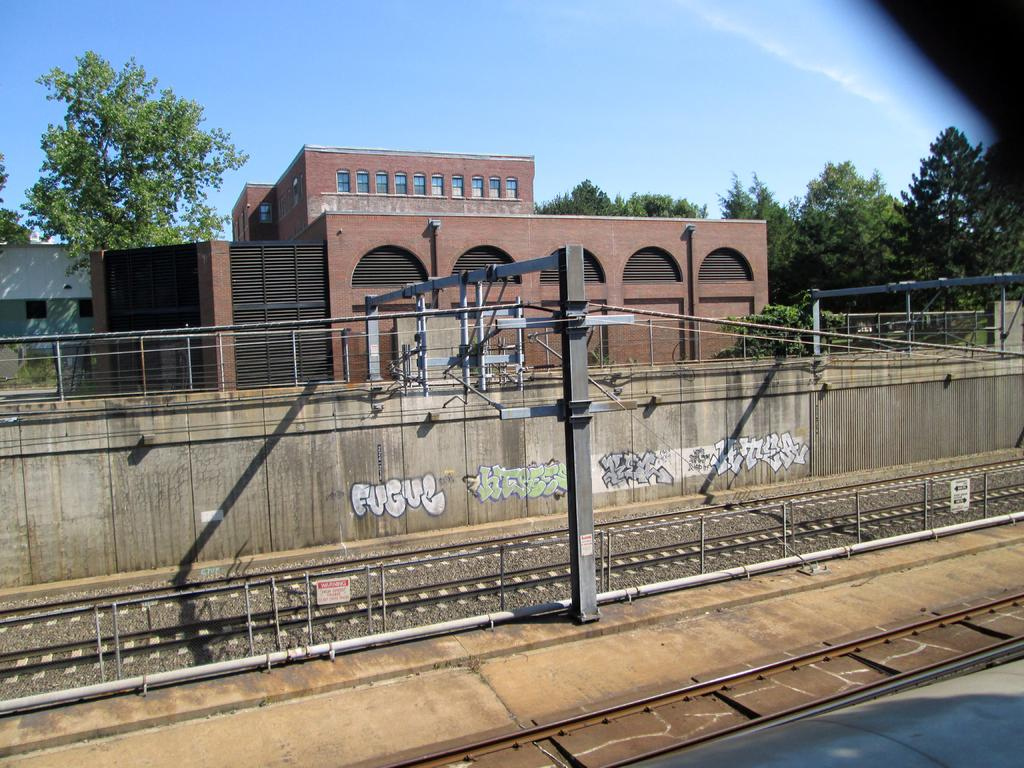What type of structures can be seen in the image? There are buildings in the image. What natural elements are present in the image? There are trees in the image. What man-made objects can be seen in the image? There are poles and wires in the image. What transportation-related feature is visible in the image? There are railway tracks in the image. What can be seen in the background of the image? The sky is visible in the background of the image. What advice is being given by the blade in the image? There is no blade present in the image, and therefore no advice can be given. Can you describe the type of fly that is visible in the image? There are no flies present in the image. 